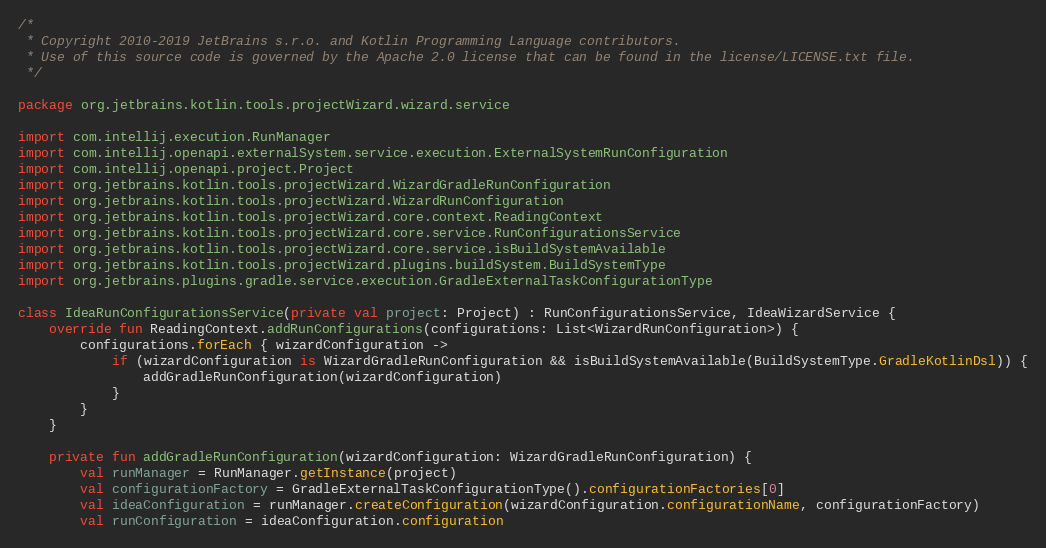Convert code to text. <code><loc_0><loc_0><loc_500><loc_500><_Kotlin_>/*
 * Copyright 2010-2019 JetBrains s.r.o. and Kotlin Programming Language contributors.
 * Use of this source code is governed by the Apache 2.0 license that can be found in the license/LICENSE.txt file.
 */

package org.jetbrains.kotlin.tools.projectWizard.wizard.service

import com.intellij.execution.RunManager
import com.intellij.openapi.externalSystem.service.execution.ExternalSystemRunConfiguration
import com.intellij.openapi.project.Project
import org.jetbrains.kotlin.tools.projectWizard.WizardGradleRunConfiguration
import org.jetbrains.kotlin.tools.projectWizard.WizardRunConfiguration
import org.jetbrains.kotlin.tools.projectWizard.core.context.ReadingContext
import org.jetbrains.kotlin.tools.projectWizard.core.service.RunConfigurationsService
import org.jetbrains.kotlin.tools.projectWizard.core.service.isBuildSystemAvailable
import org.jetbrains.kotlin.tools.projectWizard.plugins.buildSystem.BuildSystemType
import org.jetbrains.plugins.gradle.service.execution.GradleExternalTaskConfigurationType

class IdeaRunConfigurationsService(private val project: Project) : RunConfigurationsService, IdeaWizardService {
    override fun ReadingContext.addRunConfigurations(configurations: List<WizardRunConfiguration>) {
        configurations.forEach { wizardConfiguration ->
            if (wizardConfiguration is WizardGradleRunConfiguration && isBuildSystemAvailable(BuildSystemType.GradleKotlinDsl)) {
                addGradleRunConfiguration(wizardConfiguration)
            }
        }
    }

    private fun addGradleRunConfiguration(wizardConfiguration: WizardGradleRunConfiguration) {
        val runManager = RunManager.getInstance(project)
        val configurationFactory = GradleExternalTaskConfigurationType().configurationFactories[0]
        val ideaConfiguration = runManager.createConfiguration(wizardConfiguration.configurationName, configurationFactory)
        val runConfiguration = ideaConfiguration.configuration</code> 